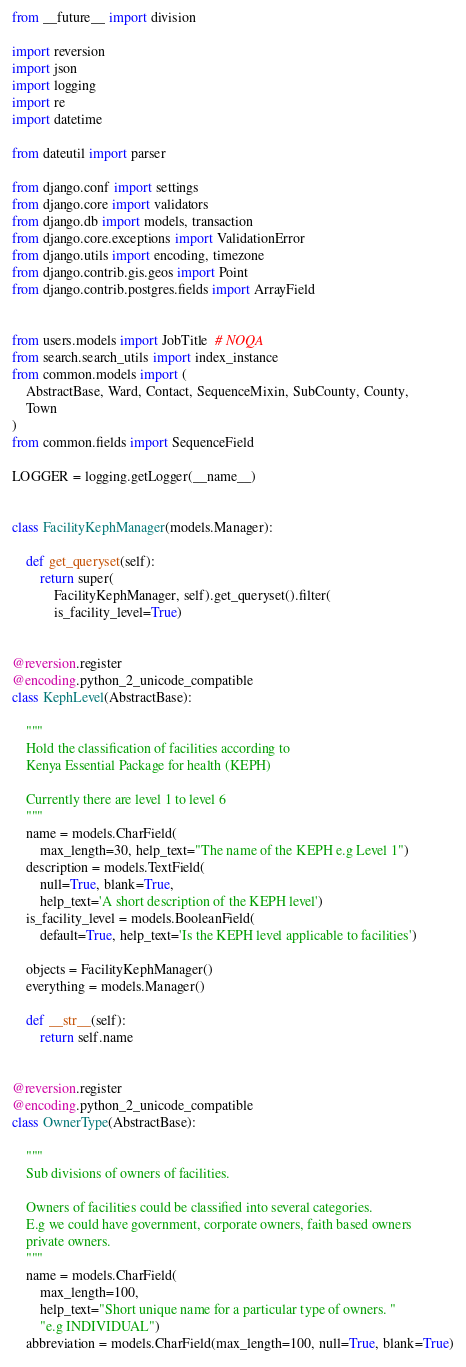Convert code to text. <code><loc_0><loc_0><loc_500><loc_500><_Python_>from __future__ import division

import reversion
import json
import logging
import re
import datetime

from dateutil import parser

from django.conf import settings
from django.core import validators
from django.db import models, transaction
from django.core.exceptions import ValidationError
from django.utils import encoding, timezone
from django.contrib.gis.geos import Point
from django.contrib.postgres.fields import ArrayField


from users.models import JobTitle  # NOQA
from search.search_utils import index_instance
from common.models import (
    AbstractBase, Ward, Contact, SequenceMixin, SubCounty, County,
    Town
)
from common.fields import SequenceField

LOGGER = logging.getLogger(__name__)


class FacilityKephManager(models.Manager):

    def get_queryset(self):
        return super(
            FacilityKephManager, self).get_queryset().filter(
            is_facility_level=True)


@reversion.register
@encoding.python_2_unicode_compatible
class KephLevel(AbstractBase):

    """
    Hold the classification of facilities according to
    Kenya Essential Package for health (KEPH)

    Currently there are level 1 to level 6
    """
    name = models.CharField(
        max_length=30, help_text="The name of the KEPH e.g Level 1")
    description = models.TextField(
        null=True, blank=True,
        help_text='A short description of the KEPH level')
    is_facility_level = models.BooleanField(
        default=True, help_text='Is the KEPH level applicable to facilities')

    objects = FacilityKephManager()
    everything = models.Manager()

    def __str__(self):
        return self.name


@reversion.register
@encoding.python_2_unicode_compatible
class OwnerType(AbstractBase):

    """
    Sub divisions of owners of facilities.

    Owners of facilities could be classified into several categories.
    E.g we could have government, corporate owners, faith based owners
    private owners.
    """
    name = models.CharField(
        max_length=100,
        help_text="Short unique name for a particular type of owners. "
        "e.g INDIVIDUAL")
    abbreviation = models.CharField(max_length=100, null=True, blank=True)</code> 